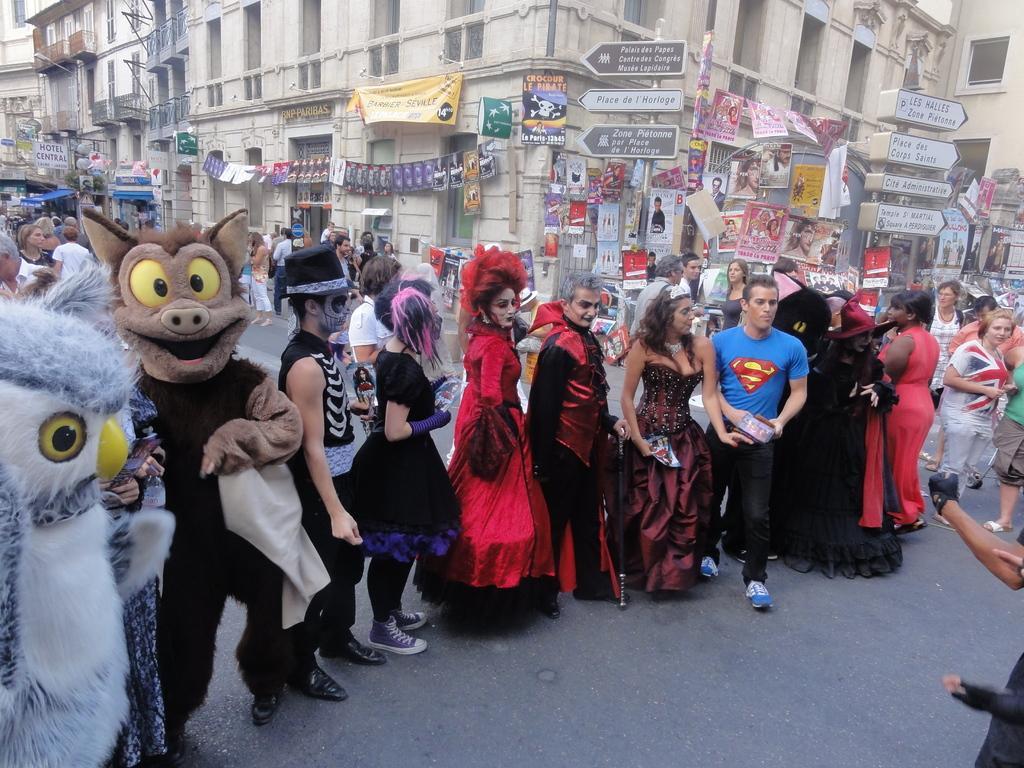Describe this image in one or two sentences. In this image, we can see a group of people are standing on the road. Here few people are wearing different costumes. Background we can see buildings, walls, posters, banners, sign boards, poles. 